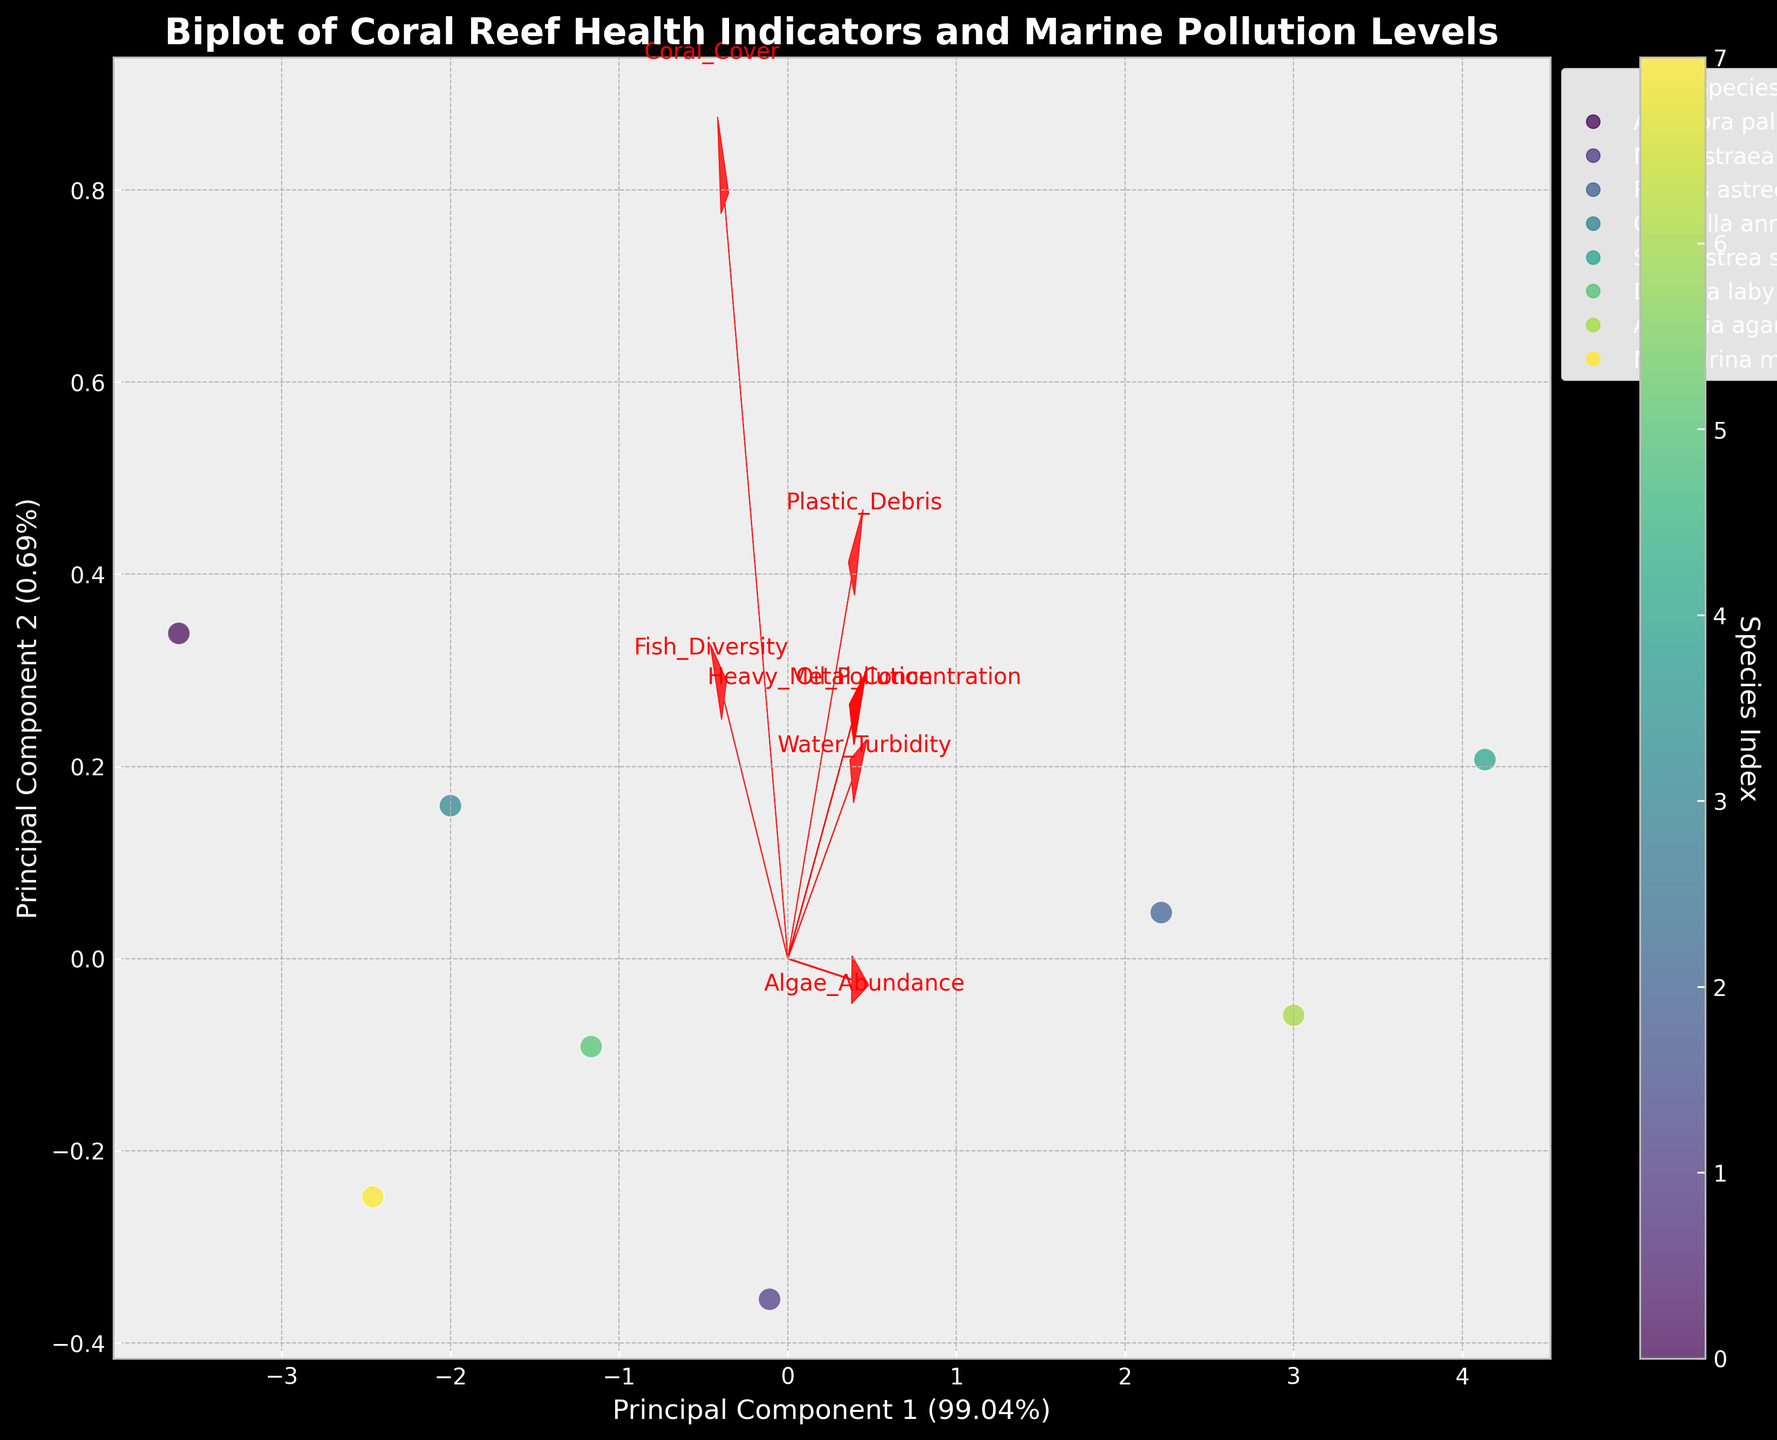How many principal components are represented in the biplot? By looking at the figure, there are two main axes, Principal Component 1 and Principal Component 2, which correspond to two principal components.
Answer: 2 Which species have the highest score on Principal Component 1? Looking at the position of data points along the Principal Component 1 axis, the species that is farthest to the right has the highest score.
Answer: Acropora palmata Which feature has the longest vector in the biplot? The length of the feature vectors can be observed; the longest vector corresponds to the feature with the largest influence on the principal components.
Answer: Plastic Debris What percentage of the variance is explained by Principal Component 1? The axis labels display the explained variance percentage for each principal component. For Principal Component 1, it is mentioned beside its axis label.
Answer: Specific percentage mentioned (will vary depending on the figure's annotations, e.g., 50.23%) How does Water Turbidity correlate with Principal Component 2? The direction and length of the Water Turbidity feature vector relative to Principal Component 2 indicates its correlation. If it points predominantly along Principal Component 2, it has a higher correlation.
Answer: Strong positive correlation What is the combined explained variance of the first two principal components? The explained variances of both Principal Component 1 and Principal Component 2 can be found and summed up to get the combined variance.
Answer: Sum of percentages (e.g., 50.23% + 27.65%) Which species is closest to the origin? Observing the scatter, the species located closest to the origin (0,0) on the biplot is the one nearest to both axes.
Answer: Specific species based on its position (e.g., Montastraea cavernosa) Are Plastic Debris and Heavy Metal Concentration positively correlated? By viewing the directions of the vectors for Plastic Debris and Heavy Metal Concentration, if they point in the same principal component direction, they are positively correlated.
Answer: Yes Which feature vector points almost in the opposite direction of Coral Cover? Identifying which vector points in nearly the opposite direction gives insight into the negative correlation with Coral Cover.
Answer: Algae Abundance Do all the species cluster closely together or are they spread out widely in the biplot? By observing the dispersion or clustering of the points on the biplot, one can determine how closely the species are grouped together.
Answer: Spread out widely 